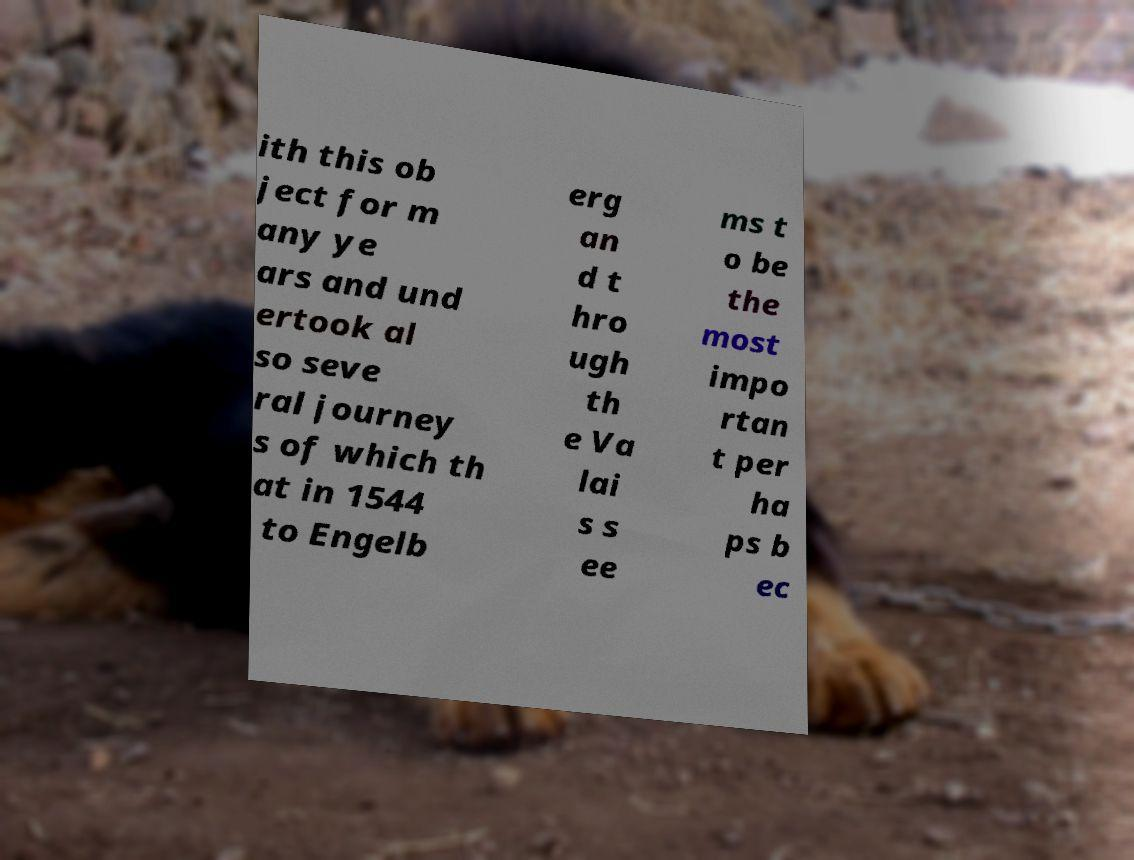Please read and relay the text visible in this image. What does it say? ith this ob ject for m any ye ars and und ertook al so seve ral journey s of which th at in 1544 to Engelb erg an d t hro ugh th e Va lai s s ee ms t o be the most impo rtan t per ha ps b ec 